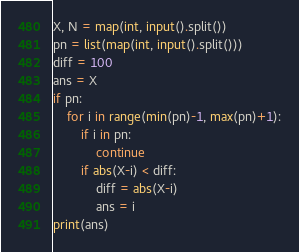Convert code to text. <code><loc_0><loc_0><loc_500><loc_500><_Python_>X, N = map(int, input().split())
pn = list(map(int, input().split()))
diff = 100
ans = X
if pn:
    for i in range(min(pn)-1, max(pn)+1):
        if i in pn:
            continue
        if abs(X-i) < diff:
            diff = abs(X-i)
            ans = i
print(ans)
</code> 